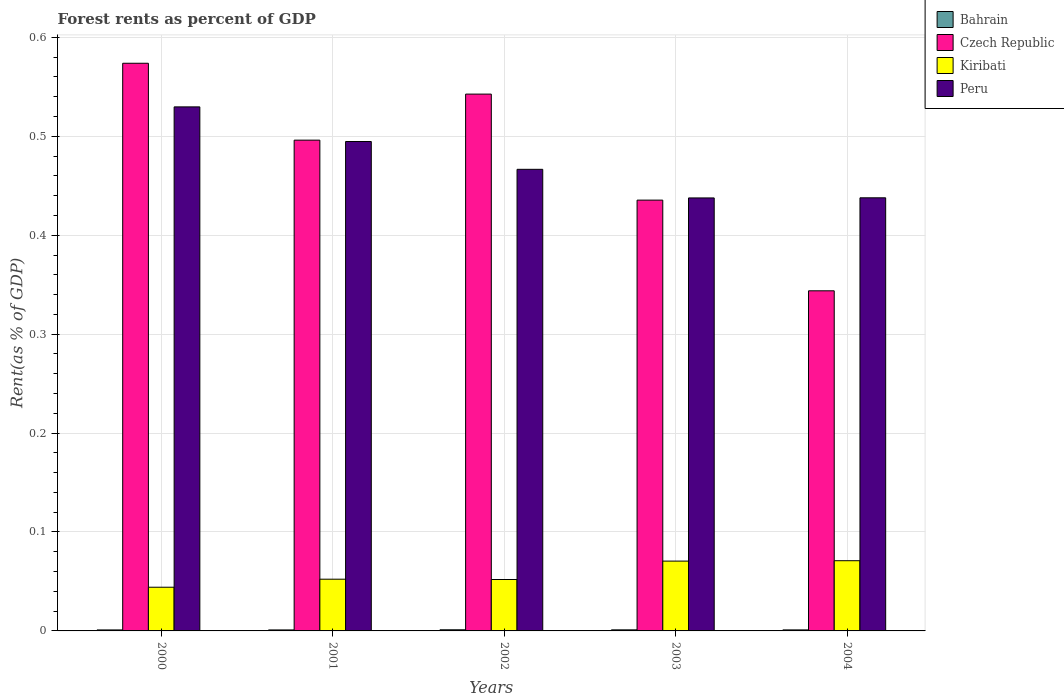How many groups of bars are there?
Your response must be concise. 5. Are the number of bars per tick equal to the number of legend labels?
Your answer should be very brief. Yes. Are the number of bars on each tick of the X-axis equal?
Make the answer very short. Yes. How many bars are there on the 2nd tick from the right?
Your answer should be very brief. 4. What is the label of the 2nd group of bars from the left?
Make the answer very short. 2001. What is the forest rent in Bahrain in 2003?
Provide a succinct answer. 0. Across all years, what is the maximum forest rent in Kiribati?
Offer a very short reply. 0.07. Across all years, what is the minimum forest rent in Peru?
Give a very brief answer. 0.44. In which year was the forest rent in Kiribati minimum?
Your answer should be very brief. 2000. What is the total forest rent in Czech Republic in the graph?
Your answer should be very brief. 2.39. What is the difference between the forest rent in Peru in 2003 and that in 2004?
Make the answer very short. -0. What is the difference between the forest rent in Bahrain in 2000 and the forest rent in Kiribati in 2001?
Your response must be concise. -0.05. What is the average forest rent in Bahrain per year?
Ensure brevity in your answer.  0. In the year 2000, what is the difference between the forest rent in Czech Republic and forest rent in Peru?
Your answer should be very brief. 0.04. In how many years, is the forest rent in Kiribati greater than 0.52 %?
Give a very brief answer. 0. What is the ratio of the forest rent in Peru in 2000 to that in 2003?
Offer a very short reply. 1.21. Is the forest rent in Czech Republic in 2001 less than that in 2004?
Give a very brief answer. No. Is the difference between the forest rent in Czech Republic in 2000 and 2004 greater than the difference between the forest rent in Peru in 2000 and 2004?
Make the answer very short. Yes. What is the difference between the highest and the second highest forest rent in Kiribati?
Your response must be concise. 0. What is the difference between the highest and the lowest forest rent in Peru?
Offer a very short reply. 0.09. In how many years, is the forest rent in Peru greater than the average forest rent in Peru taken over all years?
Offer a very short reply. 2. Is the sum of the forest rent in Bahrain in 2001 and 2002 greater than the maximum forest rent in Peru across all years?
Make the answer very short. No. What does the 3rd bar from the left in 2001 represents?
Make the answer very short. Kiribati. What does the 2nd bar from the right in 2004 represents?
Keep it short and to the point. Kiribati. How many bars are there?
Provide a short and direct response. 20. Are all the bars in the graph horizontal?
Provide a short and direct response. No. What is the difference between two consecutive major ticks on the Y-axis?
Your response must be concise. 0.1. Does the graph contain grids?
Provide a succinct answer. Yes. How many legend labels are there?
Ensure brevity in your answer.  4. How are the legend labels stacked?
Your response must be concise. Vertical. What is the title of the graph?
Your answer should be compact. Forest rents as percent of GDP. Does "Bosnia and Herzegovina" appear as one of the legend labels in the graph?
Offer a very short reply. No. What is the label or title of the X-axis?
Your answer should be very brief. Years. What is the label or title of the Y-axis?
Your answer should be very brief. Rent(as % of GDP). What is the Rent(as % of GDP) of Bahrain in 2000?
Make the answer very short. 0. What is the Rent(as % of GDP) in Czech Republic in 2000?
Offer a terse response. 0.57. What is the Rent(as % of GDP) of Kiribati in 2000?
Offer a terse response. 0.04. What is the Rent(as % of GDP) of Peru in 2000?
Give a very brief answer. 0.53. What is the Rent(as % of GDP) of Bahrain in 2001?
Your response must be concise. 0. What is the Rent(as % of GDP) of Czech Republic in 2001?
Provide a short and direct response. 0.5. What is the Rent(as % of GDP) of Kiribati in 2001?
Make the answer very short. 0.05. What is the Rent(as % of GDP) in Peru in 2001?
Ensure brevity in your answer.  0.49. What is the Rent(as % of GDP) of Bahrain in 2002?
Make the answer very short. 0. What is the Rent(as % of GDP) of Czech Republic in 2002?
Provide a short and direct response. 0.54. What is the Rent(as % of GDP) of Kiribati in 2002?
Offer a terse response. 0.05. What is the Rent(as % of GDP) in Peru in 2002?
Provide a short and direct response. 0.47. What is the Rent(as % of GDP) in Bahrain in 2003?
Ensure brevity in your answer.  0. What is the Rent(as % of GDP) of Czech Republic in 2003?
Offer a very short reply. 0.44. What is the Rent(as % of GDP) in Kiribati in 2003?
Keep it short and to the point. 0.07. What is the Rent(as % of GDP) of Peru in 2003?
Offer a terse response. 0.44. What is the Rent(as % of GDP) of Bahrain in 2004?
Ensure brevity in your answer.  0. What is the Rent(as % of GDP) in Czech Republic in 2004?
Provide a succinct answer. 0.34. What is the Rent(as % of GDP) of Kiribati in 2004?
Your answer should be compact. 0.07. What is the Rent(as % of GDP) of Peru in 2004?
Ensure brevity in your answer.  0.44. Across all years, what is the maximum Rent(as % of GDP) of Bahrain?
Your answer should be very brief. 0. Across all years, what is the maximum Rent(as % of GDP) of Czech Republic?
Provide a succinct answer. 0.57. Across all years, what is the maximum Rent(as % of GDP) in Kiribati?
Make the answer very short. 0.07. Across all years, what is the maximum Rent(as % of GDP) in Peru?
Offer a terse response. 0.53. Across all years, what is the minimum Rent(as % of GDP) in Bahrain?
Your response must be concise. 0. Across all years, what is the minimum Rent(as % of GDP) in Czech Republic?
Your answer should be compact. 0.34. Across all years, what is the minimum Rent(as % of GDP) of Kiribati?
Offer a very short reply. 0.04. Across all years, what is the minimum Rent(as % of GDP) of Peru?
Provide a short and direct response. 0.44. What is the total Rent(as % of GDP) of Bahrain in the graph?
Ensure brevity in your answer.  0.01. What is the total Rent(as % of GDP) of Czech Republic in the graph?
Offer a very short reply. 2.39. What is the total Rent(as % of GDP) in Kiribati in the graph?
Ensure brevity in your answer.  0.29. What is the total Rent(as % of GDP) in Peru in the graph?
Provide a succinct answer. 2.37. What is the difference between the Rent(as % of GDP) of Czech Republic in 2000 and that in 2001?
Ensure brevity in your answer.  0.08. What is the difference between the Rent(as % of GDP) in Kiribati in 2000 and that in 2001?
Offer a very short reply. -0.01. What is the difference between the Rent(as % of GDP) of Peru in 2000 and that in 2001?
Your response must be concise. 0.04. What is the difference between the Rent(as % of GDP) in Bahrain in 2000 and that in 2002?
Provide a short and direct response. -0. What is the difference between the Rent(as % of GDP) in Czech Republic in 2000 and that in 2002?
Ensure brevity in your answer.  0.03. What is the difference between the Rent(as % of GDP) in Kiribati in 2000 and that in 2002?
Provide a succinct answer. -0.01. What is the difference between the Rent(as % of GDP) of Peru in 2000 and that in 2002?
Your answer should be compact. 0.06. What is the difference between the Rent(as % of GDP) of Bahrain in 2000 and that in 2003?
Keep it short and to the point. -0. What is the difference between the Rent(as % of GDP) of Czech Republic in 2000 and that in 2003?
Ensure brevity in your answer.  0.14. What is the difference between the Rent(as % of GDP) of Kiribati in 2000 and that in 2003?
Offer a very short reply. -0.03. What is the difference between the Rent(as % of GDP) of Peru in 2000 and that in 2003?
Offer a very short reply. 0.09. What is the difference between the Rent(as % of GDP) of Bahrain in 2000 and that in 2004?
Offer a very short reply. -0. What is the difference between the Rent(as % of GDP) in Czech Republic in 2000 and that in 2004?
Ensure brevity in your answer.  0.23. What is the difference between the Rent(as % of GDP) of Kiribati in 2000 and that in 2004?
Keep it short and to the point. -0.03. What is the difference between the Rent(as % of GDP) in Peru in 2000 and that in 2004?
Provide a short and direct response. 0.09. What is the difference between the Rent(as % of GDP) of Bahrain in 2001 and that in 2002?
Provide a short and direct response. -0. What is the difference between the Rent(as % of GDP) in Czech Republic in 2001 and that in 2002?
Your answer should be compact. -0.05. What is the difference between the Rent(as % of GDP) in Peru in 2001 and that in 2002?
Your answer should be compact. 0.03. What is the difference between the Rent(as % of GDP) in Bahrain in 2001 and that in 2003?
Provide a succinct answer. -0. What is the difference between the Rent(as % of GDP) of Czech Republic in 2001 and that in 2003?
Make the answer very short. 0.06. What is the difference between the Rent(as % of GDP) of Kiribati in 2001 and that in 2003?
Ensure brevity in your answer.  -0.02. What is the difference between the Rent(as % of GDP) in Peru in 2001 and that in 2003?
Offer a very short reply. 0.06. What is the difference between the Rent(as % of GDP) of Bahrain in 2001 and that in 2004?
Your response must be concise. -0. What is the difference between the Rent(as % of GDP) in Czech Republic in 2001 and that in 2004?
Your response must be concise. 0.15. What is the difference between the Rent(as % of GDP) in Kiribati in 2001 and that in 2004?
Provide a succinct answer. -0.02. What is the difference between the Rent(as % of GDP) of Peru in 2001 and that in 2004?
Keep it short and to the point. 0.06. What is the difference between the Rent(as % of GDP) of Bahrain in 2002 and that in 2003?
Make the answer very short. 0. What is the difference between the Rent(as % of GDP) in Czech Republic in 2002 and that in 2003?
Your response must be concise. 0.11. What is the difference between the Rent(as % of GDP) of Kiribati in 2002 and that in 2003?
Your answer should be very brief. -0.02. What is the difference between the Rent(as % of GDP) of Peru in 2002 and that in 2003?
Your answer should be very brief. 0.03. What is the difference between the Rent(as % of GDP) of Czech Republic in 2002 and that in 2004?
Your answer should be very brief. 0.2. What is the difference between the Rent(as % of GDP) in Kiribati in 2002 and that in 2004?
Provide a succinct answer. -0.02. What is the difference between the Rent(as % of GDP) of Peru in 2002 and that in 2004?
Offer a terse response. 0.03. What is the difference between the Rent(as % of GDP) of Bahrain in 2003 and that in 2004?
Your answer should be compact. 0. What is the difference between the Rent(as % of GDP) in Czech Republic in 2003 and that in 2004?
Offer a very short reply. 0.09. What is the difference between the Rent(as % of GDP) in Kiribati in 2003 and that in 2004?
Give a very brief answer. -0. What is the difference between the Rent(as % of GDP) in Peru in 2003 and that in 2004?
Provide a succinct answer. -0. What is the difference between the Rent(as % of GDP) in Bahrain in 2000 and the Rent(as % of GDP) in Czech Republic in 2001?
Your response must be concise. -0.5. What is the difference between the Rent(as % of GDP) of Bahrain in 2000 and the Rent(as % of GDP) of Kiribati in 2001?
Provide a succinct answer. -0.05. What is the difference between the Rent(as % of GDP) in Bahrain in 2000 and the Rent(as % of GDP) in Peru in 2001?
Make the answer very short. -0.49. What is the difference between the Rent(as % of GDP) in Czech Republic in 2000 and the Rent(as % of GDP) in Kiribati in 2001?
Give a very brief answer. 0.52. What is the difference between the Rent(as % of GDP) in Czech Republic in 2000 and the Rent(as % of GDP) in Peru in 2001?
Offer a very short reply. 0.08. What is the difference between the Rent(as % of GDP) of Kiribati in 2000 and the Rent(as % of GDP) of Peru in 2001?
Make the answer very short. -0.45. What is the difference between the Rent(as % of GDP) of Bahrain in 2000 and the Rent(as % of GDP) of Czech Republic in 2002?
Provide a succinct answer. -0.54. What is the difference between the Rent(as % of GDP) in Bahrain in 2000 and the Rent(as % of GDP) in Kiribati in 2002?
Your response must be concise. -0.05. What is the difference between the Rent(as % of GDP) in Bahrain in 2000 and the Rent(as % of GDP) in Peru in 2002?
Provide a short and direct response. -0.47. What is the difference between the Rent(as % of GDP) in Czech Republic in 2000 and the Rent(as % of GDP) in Kiribati in 2002?
Provide a succinct answer. 0.52. What is the difference between the Rent(as % of GDP) of Czech Republic in 2000 and the Rent(as % of GDP) of Peru in 2002?
Offer a very short reply. 0.11. What is the difference between the Rent(as % of GDP) in Kiribati in 2000 and the Rent(as % of GDP) in Peru in 2002?
Provide a short and direct response. -0.42. What is the difference between the Rent(as % of GDP) of Bahrain in 2000 and the Rent(as % of GDP) of Czech Republic in 2003?
Your response must be concise. -0.43. What is the difference between the Rent(as % of GDP) of Bahrain in 2000 and the Rent(as % of GDP) of Kiribati in 2003?
Offer a terse response. -0.07. What is the difference between the Rent(as % of GDP) in Bahrain in 2000 and the Rent(as % of GDP) in Peru in 2003?
Your answer should be very brief. -0.44. What is the difference between the Rent(as % of GDP) of Czech Republic in 2000 and the Rent(as % of GDP) of Kiribati in 2003?
Your response must be concise. 0.5. What is the difference between the Rent(as % of GDP) of Czech Republic in 2000 and the Rent(as % of GDP) of Peru in 2003?
Offer a very short reply. 0.14. What is the difference between the Rent(as % of GDP) of Kiribati in 2000 and the Rent(as % of GDP) of Peru in 2003?
Your response must be concise. -0.39. What is the difference between the Rent(as % of GDP) of Bahrain in 2000 and the Rent(as % of GDP) of Czech Republic in 2004?
Offer a very short reply. -0.34. What is the difference between the Rent(as % of GDP) in Bahrain in 2000 and the Rent(as % of GDP) in Kiribati in 2004?
Offer a terse response. -0.07. What is the difference between the Rent(as % of GDP) in Bahrain in 2000 and the Rent(as % of GDP) in Peru in 2004?
Make the answer very short. -0.44. What is the difference between the Rent(as % of GDP) of Czech Republic in 2000 and the Rent(as % of GDP) of Kiribati in 2004?
Make the answer very short. 0.5. What is the difference between the Rent(as % of GDP) in Czech Republic in 2000 and the Rent(as % of GDP) in Peru in 2004?
Give a very brief answer. 0.14. What is the difference between the Rent(as % of GDP) in Kiribati in 2000 and the Rent(as % of GDP) in Peru in 2004?
Offer a terse response. -0.39. What is the difference between the Rent(as % of GDP) of Bahrain in 2001 and the Rent(as % of GDP) of Czech Republic in 2002?
Make the answer very short. -0.54. What is the difference between the Rent(as % of GDP) of Bahrain in 2001 and the Rent(as % of GDP) of Kiribati in 2002?
Offer a terse response. -0.05. What is the difference between the Rent(as % of GDP) of Bahrain in 2001 and the Rent(as % of GDP) of Peru in 2002?
Give a very brief answer. -0.47. What is the difference between the Rent(as % of GDP) in Czech Republic in 2001 and the Rent(as % of GDP) in Kiribati in 2002?
Give a very brief answer. 0.44. What is the difference between the Rent(as % of GDP) in Czech Republic in 2001 and the Rent(as % of GDP) in Peru in 2002?
Ensure brevity in your answer.  0.03. What is the difference between the Rent(as % of GDP) of Kiribati in 2001 and the Rent(as % of GDP) of Peru in 2002?
Make the answer very short. -0.41. What is the difference between the Rent(as % of GDP) in Bahrain in 2001 and the Rent(as % of GDP) in Czech Republic in 2003?
Ensure brevity in your answer.  -0.43. What is the difference between the Rent(as % of GDP) in Bahrain in 2001 and the Rent(as % of GDP) in Kiribati in 2003?
Provide a short and direct response. -0.07. What is the difference between the Rent(as % of GDP) in Bahrain in 2001 and the Rent(as % of GDP) in Peru in 2003?
Offer a very short reply. -0.44. What is the difference between the Rent(as % of GDP) of Czech Republic in 2001 and the Rent(as % of GDP) of Kiribati in 2003?
Make the answer very short. 0.43. What is the difference between the Rent(as % of GDP) in Czech Republic in 2001 and the Rent(as % of GDP) in Peru in 2003?
Offer a terse response. 0.06. What is the difference between the Rent(as % of GDP) of Kiribati in 2001 and the Rent(as % of GDP) of Peru in 2003?
Offer a very short reply. -0.39. What is the difference between the Rent(as % of GDP) of Bahrain in 2001 and the Rent(as % of GDP) of Czech Republic in 2004?
Provide a short and direct response. -0.34. What is the difference between the Rent(as % of GDP) in Bahrain in 2001 and the Rent(as % of GDP) in Kiribati in 2004?
Keep it short and to the point. -0.07. What is the difference between the Rent(as % of GDP) in Bahrain in 2001 and the Rent(as % of GDP) in Peru in 2004?
Your answer should be compact. -0.44. What is the difference between the Rent(as % of GDP) of Czech Republic in 2001 and the Rent(as % of GDP) of Kiribati in 2004?
Give a very brief answer. 0.43. What is the difference between the Rent(as % of GDP) of Czech Republic in 2001 and the Rent(as % of GDP) of Peru in 2004?
Give a very brief answer. 0.06. What is the difference between the Rent(as % of GDP) in Kiribati in 2001 and the Rent(as % of GDP) in Peru in 2004?
Your response must be concise. -0.39. What is the difference between the Rent(as % of GDP) of Bahrain in 2002 and the Rent(as % of GDP) of Czech Republic in 2003?
Provide a short and direct response. -0.43. What is the difference between the Rent(as % of GDP) of Bahrain in 2002 and the Rent(as % of GDP) of Kiribati in 2003?
Make the answer very short. -0.07. What is the difference between the Rent(as % of GDP) in Bahrain in 2002 and the Rent(as % of GDP) in Peru in 2003?
Offer a terse response. -0.44. What is the difference between the Rent(as % of GDP) of Czech Republic in 2002 and the Rent(as % of GDP) of Kiribati in 2003?
Give a very brief answer. 0.47. What is the difference between the Rent(as % of GDP) of Czech Republic in 2002 and the Rent(as % of GDP) of Peru in 2003?
Your answer should be very brief. 0.1. What is the difference between the Rent(as % of GDP) of Kiribati in 2002 and the Rent(as % of GDP) of Peru in 2003?
Provide a short and direct response. -0.39. What is the difference between the Rent(as % of GDP) of Bahrain in 2002 and the Rent(as % of GDP) of Czech Republic in 2004?
Give a very brief answer. -0.34. What is the difference between the Rent(as % of GDP) of Bahrain in 2002 and the Rent(as % of GDP) of Kiribati in 2004?
Keep it short and to the point. -0.07. What is the difference between the Rent(as % of GDP) in Bahrain in 2002 and the Rent(as % of GDP) in Peru in 2004?
Your answer should be very brief. -0.44. What is the difference between the Rent(as % of GDP) in Czech Republic in 2002 and the Rent(as % of GDP) in Kiribati in 2004?
Keep it short and to the point. 0.47. What is the difference between the Rent(as % of GDP) in Czech Republic in 2002 and the Rent(as % of GDP) in Peru in 2004?
Provide a succinct answer. 0.1. What is the difference between the Rent(as % of GDP) of Kiribati in 2002 and the Rent(as % of GDP) of Peru in 2004?
Your answer should be very brief. -0.39. What is the difference between the Rent(as % of GDP) in Bahrain in 2003 and the Rent(as % of GDP) in Czech Republic in 2004?
Ensure brevity in your answer.  -0.34. What is the difference between the Rent(as % of GDP) of Bahrain in 2003 and the Rent(as % of GDP) of Kiribati in 2004?
Ensure brevity in your answer.  -0.07. What is the difference between the Rent(as % of GDP) of Bahrain in 2003 and the Rent(as % of GDP) of Peru in 2004?
Keep it short and to the point. -0.44. What is the difference between the Rent(as % of GDP) in Czech Republic in 2003 and the Rent(as % of GDP) in Kiribati in 2004?
Offer a terse response. 0.36. What is the difference between the Rent(as % of GDP) in Czech Republic in 2003 and the Rent(as % of GDP) in Peru in 2004?
Your answer should be compact. -0. What is the difference between the Rent(as % of GDP) of Kiribati in 2003 and the Rent(as % of GDP) of Peru in 2004?
Your response must be concise. -0.37. What is the average Rent(as % of GDP) in Bahrain per year?
Offer a very short reply. 0. What is the average Rent(as % of GDP) in Czech Republic per year?
Give a very brief answer. 0.48. What is the average Rent(as % of GDP) in Kiribati per year?
Offer a terse response. 0.06. What is the average Rent(as % of GDP) of Peru per year?
Your response must be concise. 0.47. In the year 2000, what is the difference between the Rent(as % of GDP) of Bahrain and Rent(as % of GDP) of Czech Republic?
Offer a very short reply. -0.57. In the year 2000, what is the difference between the Rent(as % of GDP) in Bahrain and Rent(as % of GDP) in Kiribati?
Provide a succinct answer. -0.04. In the year 2000, what is the difference between the Rent(as % of GDP) of Bahrain and Rent(as % of GDP) of Peru?
Make the answer very short. -0.53. In the year 2000, what is the difference between the Rent(as % of GDP) of Czech Republic and Rent(as % of GDP) of Kiribati?
Keep it short and to the point. 0.53. In the year 2000, what is the difference between the Rent(as % of GDP) of Czech Republic and Rent(as % of GDP) of Peru?
Your response must be concise. 0.04. In the year 2000, what is the difference between the Rent(as % of GDP) in Kiribati and Rent(as % of GDP) in Peru?
Your answer should be very brief. -0.49. In the year 2001, what is the difference between the Rent(as % of GDP) in Bahrain and Rent(as % of GDP) in Czech Republic?
Your answer should be compact. -0.5. In the year 2001, what is the difference between the Rent(as % of GDP) in Bahrain and Rent(as % of GDP) in Kiribati?
Ensure brevity in your answer.  -0.05. In the year 2001, what is the difference between the Rent(as % of GDP) in Bahrain and Rent(as % of GDP) in Peru?
Your response must be concise. -0.49. In the year 2001, what is the difference between the Rent(as % of GDP) of Czech Republic and Rent(as % of GDP) of Kiribati?
Keep it short and to the point. 0.44. In the year 2001, what is the difference between the Rent(as % of GDP) in Czech Republic and Rent(as % of GDP) in Peru?
Offer a terse response. 0. In the year 2001, what is the difference between the Rent(as % of GDP) of Kiribati and Rent(as % of GDP) of Peru?
Make the answer very short. -0.44. In the year 2002, what is the difference between the Rent(as % of GDP) of Bahrain and Rent(as % of GDP) of Czech Republic?
Offer a very short reply. -0.54. In the year 2002, what is the difference between the Rent(as % of GDP) in Bahrain and Rent(as % of GDP) in Kiribati?
Your answer should be compact. -0.05. In the year 2002, what is the difference between the Rent(as % of GDP) of Bahrain and Rent(as % of GDP) of Peru?
Your answer should be very brief. -0.47. In the year 2002, what is the difference between the Rent(as % of GDP) in Czech Republic and Rent(as % of GDP) in Kiribati?
Offer a very short reply. 0.49. In the year 2002, what is the difference between the Rent(as % of GDP) in Czech Republic and Rent(as % of GDP) in Peru?
Your answer should be compact. 0.08. In the year 2002, what is the difference between the Rent(as % of GDP) in Kiribati and Rent(as % of GDP) in Peru?
Make the answer very short. -0.41. In the year 2003, what is the difference between the Rent(as % of GDP) in Bahrain and Rent(as % of GDP) in Czech Republic?
Provide a succinct answer. -0.43. In the year 2003, what is the difference between the Rent(as % of GDP) in Bahrain and Rent(as % of GDP) in Kiribati?
Offer a terse response. -0.07. In the year 2003, what is the difference between the Rent(as % of GDP) of Bahrain and Rent(as % of GDP) of Peru?
Your answer should be very brief. -0.44. In the year 2003, what is the difference between the Rent(as % of GDP) in Czech Republic and Rent(as % of GDP) in Kiribati?
Offer a very short reply. 0.36. In the year 2003, what is the difference between the Rent(as % of GDP) of Czech Republic and Rent(as % of GDP) of Peru?
Your answer should be compact. -0. In the year 2003, what is the difference between the Rent(as % of GDP) of Kiribati and Rent(as % of GDP) of Peru?
Your answer should be very brief. -0.37. In the year 2004, what is the difference between the Rent(as % of GDP) in Bahrain and Rent(as % of GDP) in Czech Republic?
Offer a terse response. -0.34. In the year 2004, what is the difference between the Rent(as % of GDP) in Bahrain and Rent(as % of GDP) in Kiribati?
Make the answer very short. -0.07. In the year 2004, what is the difference between the Rent(as % of GDP) in Bahrain and Rent(as % of GDP) in Peru?
Give a very brief answer. -0.44. In the year 2004, what is the difference between the Rent(as % of GDP) in Czech Republic and Rent(as % of GDP) in Kiribati?
Your answer should be very brief. 0.27. In the year 2004, what is the difference between the Rent(as % of GDP) of Czech Republic and Rent(as % of GDP) of Peru?
Give a very brief answer. -0.09. In the year 2004, what is the difference between the Rent(as % of GDP) in Kiribati and Rent(as % of GDP) in Peru?
Offer a very short reply. -0.37. What is the ratio of the Rent(as % of GDP) of Bahrain in 2000 to that in 2001?
Keep it short and to the point. 1.01. What is the ratio of the Rent(as % of GDP) of Czech Republic in 2000 to that in 2001?
Your answer should be compact. 1.16. What is the ratio of the Rent(as % of GDP) of Kiribati in 2000 to that in 2001?
Keep it short and to the point. 0.84. What is the ratio of the Rent(as % of GDP) of Peru in 2000 to that in 2001?
Keep it short and to the point. 1.07. What is the ratio of the Rent(as % of GDP) of Bahrain in 2000 to that in 2002?
Make the answer very short. 0.88. What is the ratio of the Rent(as % of GDP) in Czech Republic in 2000 to that in 2002?
Keep it short and to the point. 1.06. What is the ratio of the Rent(as % of GDP) of Kiribati in 2000 to that in 2002?
Your answer should be very brief. 0.85. What is the ratio of the Rent(as % of GDP) in Peru in 2000 to that in 2002?
Make the answer very short. 1.14. What is the ratio of the Rent(as % of GDP) of Bahrain in 2000 to that in 2003?
Provide a short and direct response. 0.93. What is the ratio of the Rent(as % of GDP) of Czech Republic in 2000 to that in 2003?
Provide a succinct answer. 1.32. What is the ratio of the Rent(as % of GDP) in Kiribati in 2000 to that in 2003?
Offer a terse response. 0.63. What is the ratio of the Rent(as % of GDP) of Peru in 2000 to that in 2003?
Offer a terse response. 1.21. What is the ratio of the Rent(as % of GDP) of Bahrain in 2000 to that in 2004?
Provide a short and direct response. 0.98. What is the ratio of the Rent(as % of GDP) in Czech Republic in 2000 to that in 2004?
Provide a short and direct response. 1.67. What is the ratio of the Rent(as % of GDP) in Kiribati in 2000 to that in 2004?
Give a very brief answer. 0.62. What is the ratio of the Rent(as % of GDP) in Peru in 2000 to that in 2004?
Your response must be concise. 1.21. What is the ratio of the Rent(as % of GDP) of Bahrain in 2001 to that in 2002?
Give a very brief answer. 0.87. What is the ratio of the Rent(as % of GDP) in Czech Republic in 2001 to that in 2002?
Make the answer very short. 0.91. What is the ratio of the Rent(as % of GDP) in Peru in 2001 to that in 2002?
Keep it short and to the point. 1.06. What is the ratio of the Rent(as % of GDP) in Bahrain in 2001 to that in 2003?
Give a very brief answer. 0.92. What is the ratio of the Rent(as % of GDP) in Czech Republic in 2001 to that in 2003?
Provide a succinct answer. 1.14. What is the ratio of the Rent(as % of GDP) in Kiribati in 2001 to that in 2003?
Offer a very short reply. 0.74. What is the ratio of the Rent(as % of GDP) of Peru in 2001 to that in 2003?
Provide a short and direct response. 1.13. What is the ratio of the Rent(as % of GDP) of Bahrain in 2001 to that in 2004?
Your response must be concise. 0.97. What is the ratio of the Rent(as % of GDP) in Czech Republic in 2001 to that in 2004?
Your answer should be very brief. 1.44. What is the ratio of the Rent(as % of GDP) in Kiribati in 2001 to that in 2004?
Keep it short and to the point. 0.74. What is the ratio of the Rent(as % of GDP) in Peru in 2001 to that in 2004?
Give a very brief answer. 1.13. What is the ratio of the Rent(as % of GDP) of Bahrain in 2002 to that in 2003?
Offer a very short reply. 1.06. What is the ratio of the Rent(as % of GDP) in Czech Republic in 2002 to that in 2003?
Your response must be concise. 1.25. What is the ratio of the Rent(as % of GDP) of Kiribati in 2002 to that in 2003?
Your answer should be compact. 0.74. What is the ratio of the Rent(as % of GDP) in Peru in 2002 to that in 2003?
Your answer should be very brief. 1.07. What is the ratio of the Rent(as % of GDP) of Bahrain in 2002 to that in 2004?
Provide a succinct answer. 1.12. What is the ratio of the Rent(as % of GDP) in Czech Republic in 2002 to that in 2004?
Your response must be concise. 1.58. What is the ratio of the Rent(as % of GDP) of Kiribati in 2002 to that in 2004?
Your answer should be very brief. 0.73. What is the ratio of the Rent(as % of GDP) of Peru in 2002 to that in 2004?
Make the answer very short. 1.07. What is the ratio of the Rent(as % of GDP) in Bahrain in 2003 to that in 2004?
Your answer should be very brief. 1.05. What is the ratio of the Rent(as % of GDP) of Czech Republic in 2003 to that in 2004?
Provide a succinct answer. 1.27. What is the ratio of the Rent(as % of GDP) of Kiribati in 2003 to that in 2004?
Make the answer very short. 0.99. What is the difference between the highest and the second highest Rent(as % of GDP) in Czech Republic?
Your answer should be very brief. 0.03. What is the difference between the highest and the second highest Rent(as % of GDP) of Peru?
Make the answer very short. 0.04. What is the difference between the highest and the lowest Rent(as % of GDP) of Bahrain?
Your answer should be compact. 0. What is the difference between the highest and the lowest Rent(as % of GDP) in Czech Republic?
Keep it short and to the point. 0.23. What is the difference between the highest and the lowest Rent(as % of GDP) of Kiribati?
Offer a very short reply. 0.03. What is the difference between the highest and the lowest Rent(as % of GDP) in Peru?
Give a very brief answer. 0.09. 